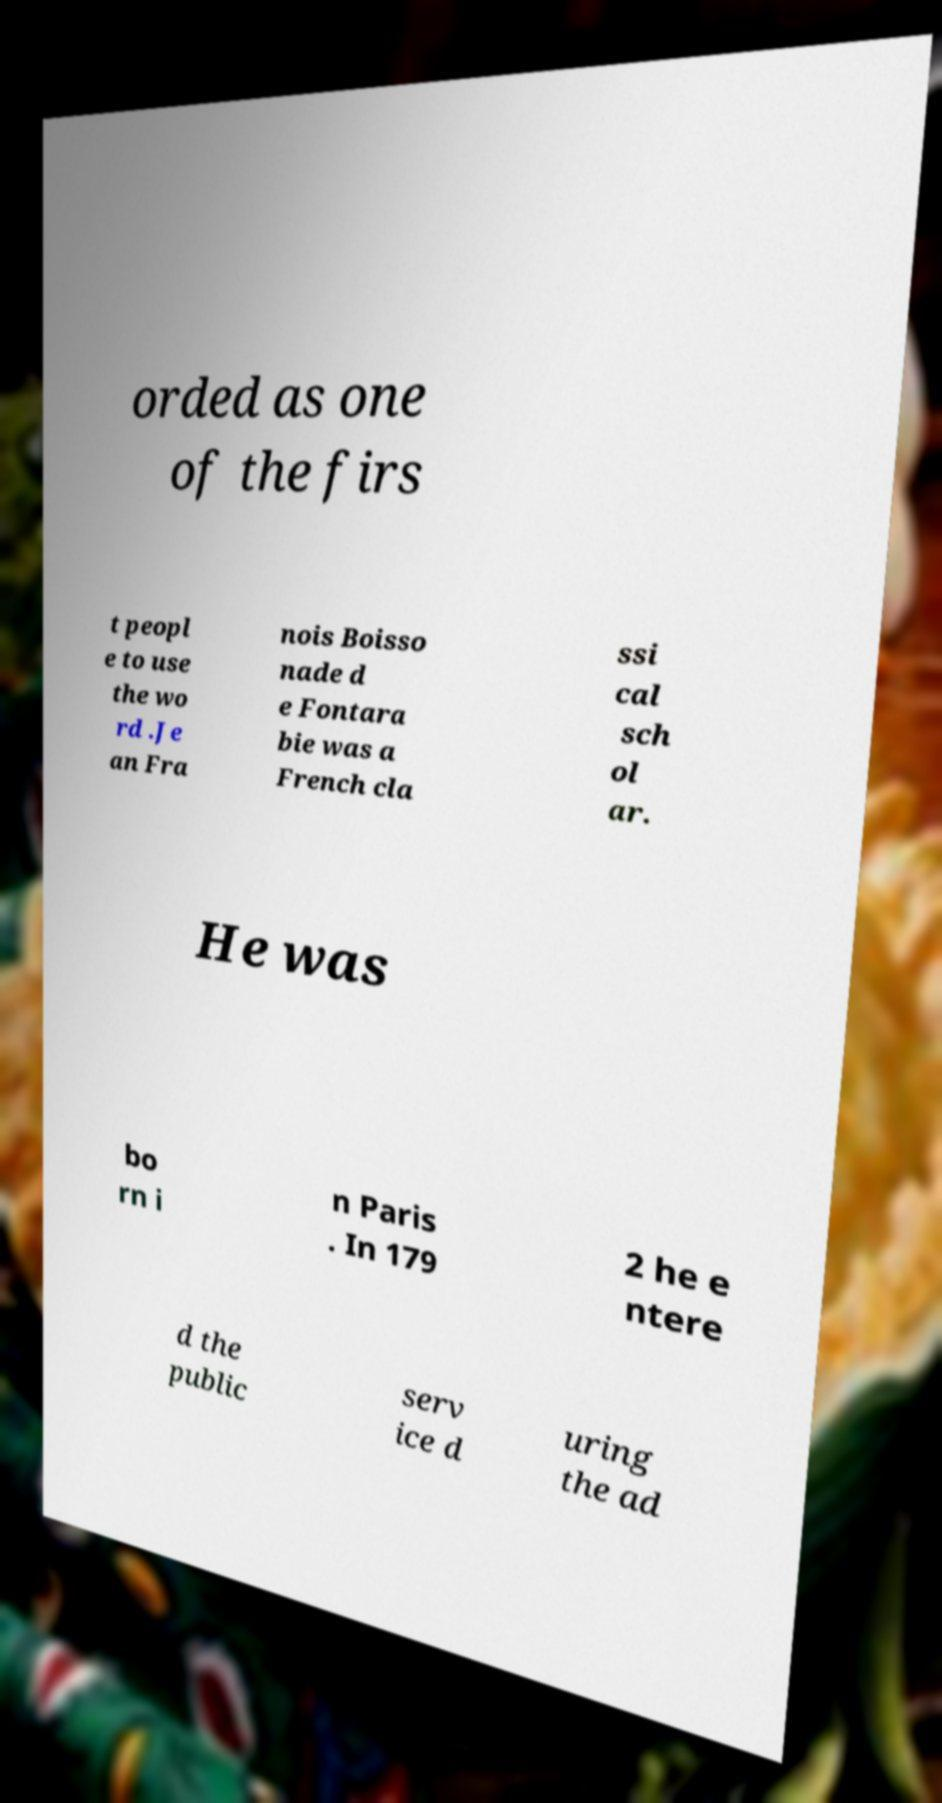Can you read and provide the text displayed in the image?This photo seems to have some interesting text. Can you extract and type it out for me? orded as one of the firs t peopl e to use the wo rd .Je an Fra nois Boisso nade d e Fontara bie was a French cla ssi cal sch ol ar. He was bo rn i n Paris . In 179 2 he e ntere d the public serv ice d uring the ad 